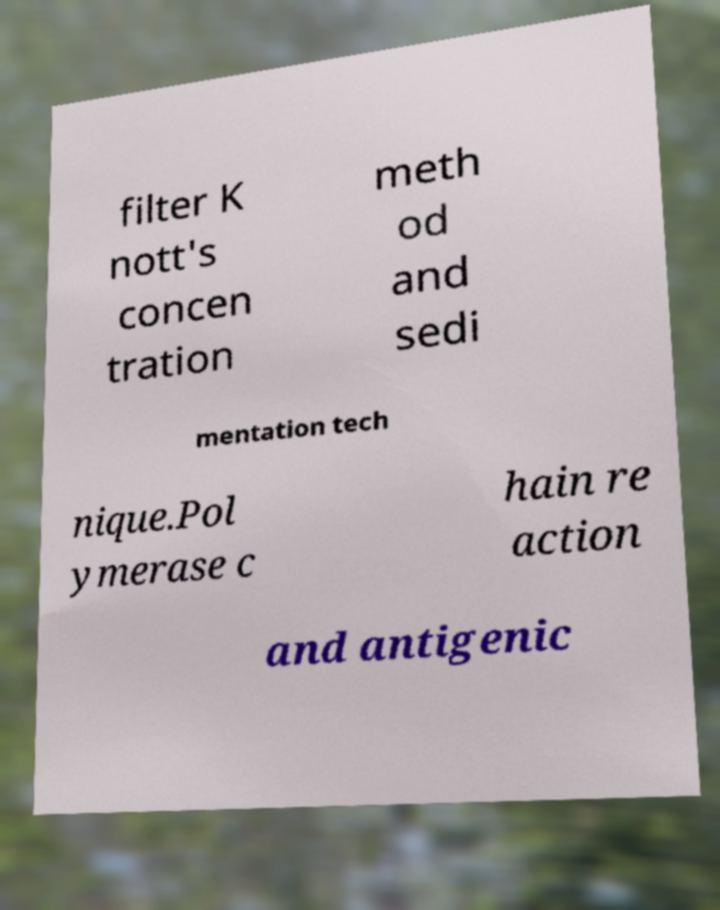For documentation purposes, I need the text within this image transcribed. Could you provide that? filter K nott's concen tration meth od and sedi mentation tech nique.Pol ymerase c hain re action and antigenic 